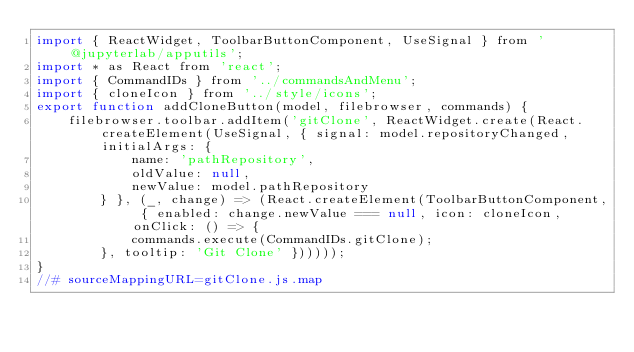<code> <loc_0><loc_0><loc_500><loc_500><_JavaScript_>import { ReactWidget, ToolbarButtonComponent, UseSignal } from '@jupyterlab/apputils';
import * as React from 'react';
import { CommandIDs } from '../commandsAndMenu';
import { cloneIcon } from '../style/icons';
export function addCloneButton(model, filebrowser, commands) {
    filebrowser.toolbar.addItem('gitClone', ReactWidget.create(React.createElement(UseSignal, { signal: model.repositoryChanged, initialArgs: {
            name: 'pathRepository',
            oldValue: null,
            newValue: model.pathRepository
        } }, (_, change) => (React.createElement(ToolbarButtonComponent, { enabled: change.newValue === null, icon: cloneIcon, onClick: () => {
            commands.execute(CommandIDs.gitClone);
        }, tooltip: 'Git Clone' })))));
}
//# sourceMappingURL=gitClone.js.map</code> 